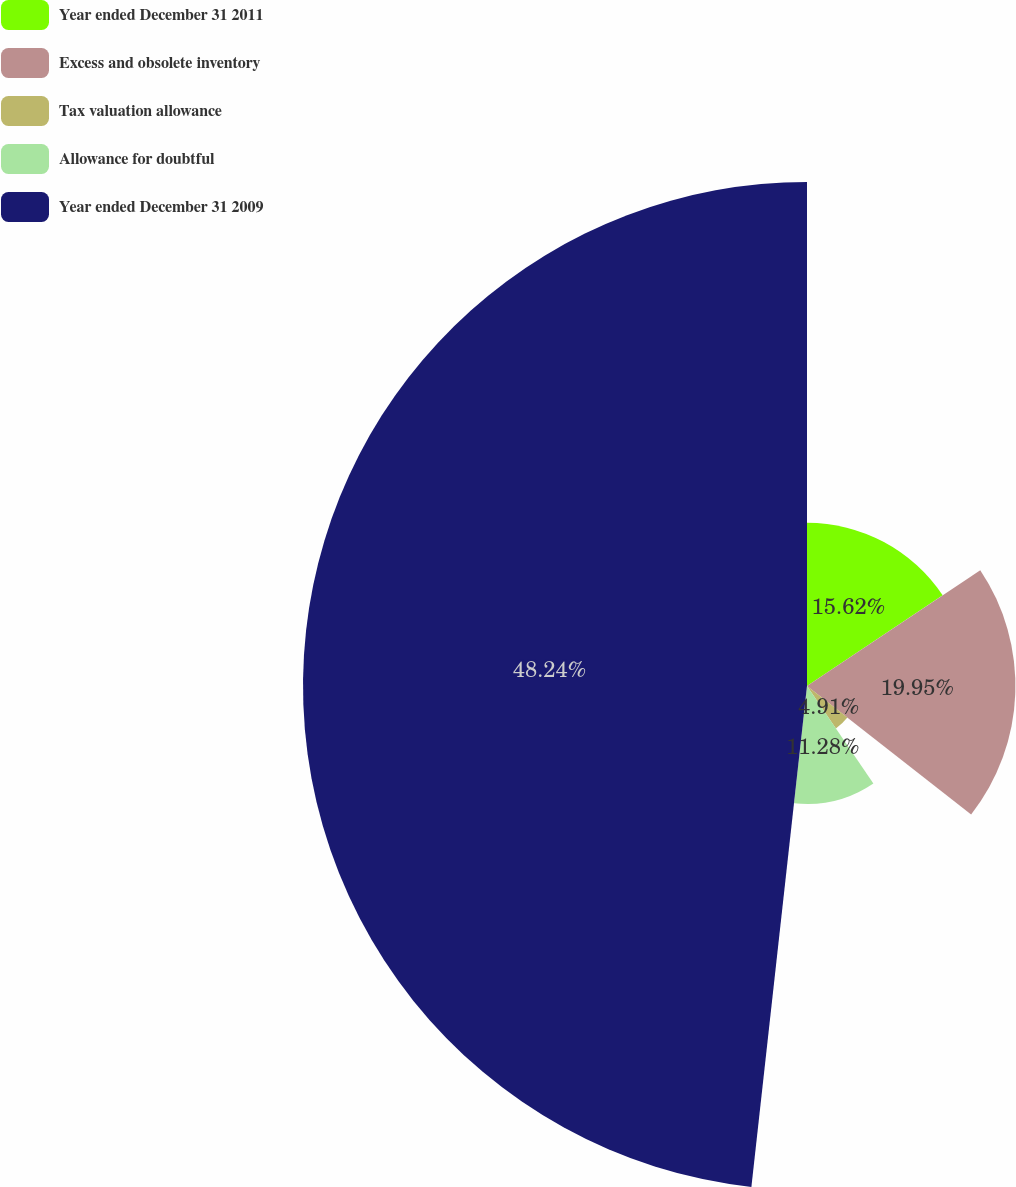Convert chart. <chart><loc_0><loc_0><loc_500><loc_500><pie_chart><fcel>Year ended December 31 2011<fcel>Excess and obsolete inventory<fcel>Tax valuation allowance<fcel>Allowance for doubtful<fcel>Year ended December 31 2009<nl><fcel>15.62%<fcel>19.95%<fcel>4.91%<fcel>11.28%<fcel>48.24%<nl></chart> 